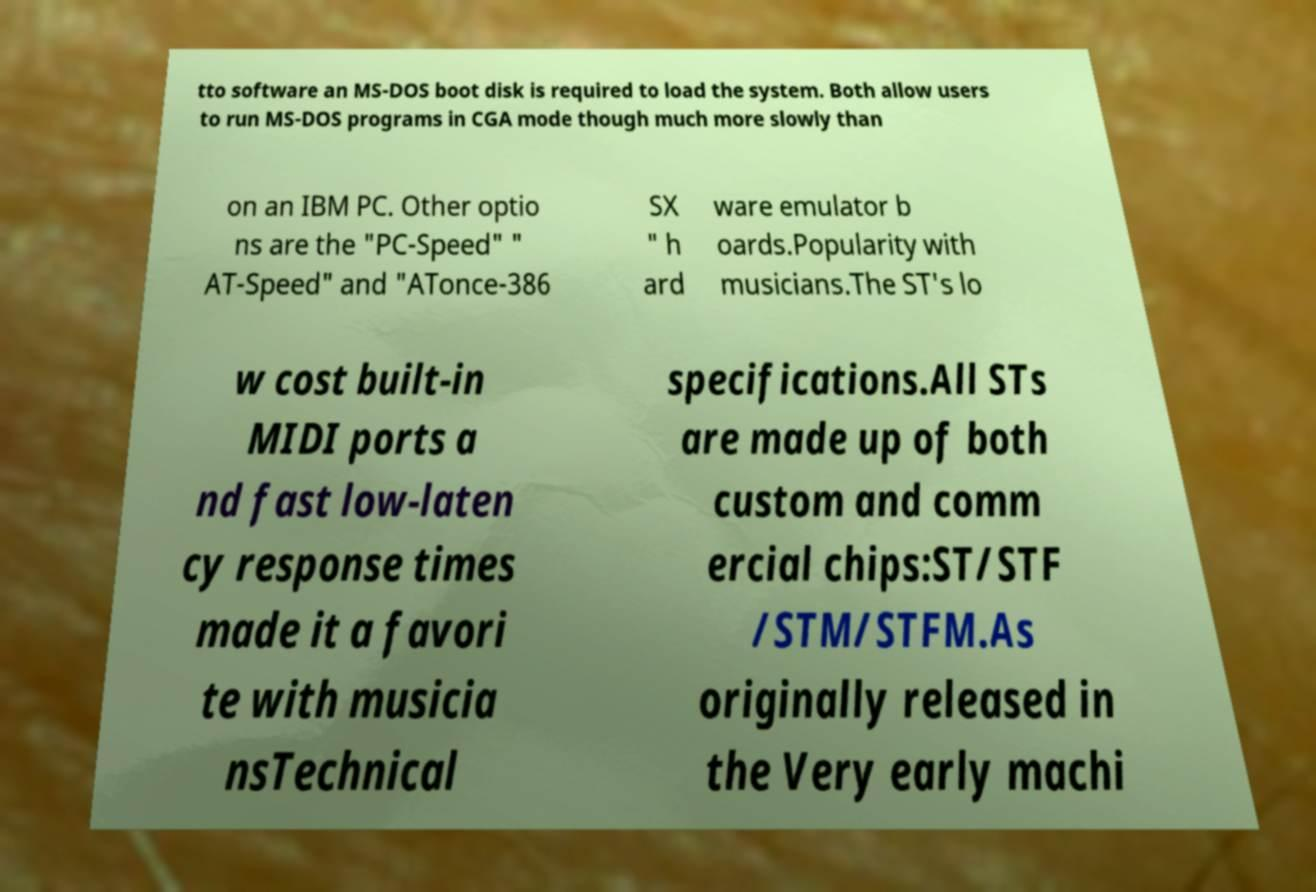For documentation purposes, I need the text within this image transcribed. Could you provide that? tto software an MS-DOS boot disk is required to load the system. Both allow users to run MS-DOS programs in CGA mode though much more slowly than on an IBM PC. Other optio ns are the "PC-Speed" " AT-Speed" and "ATonce-386 SX " h ard ware emulator b oards.Popularity with musicians.The ST's lo w cost built-in MIDI ports a nd fast low-laten cy response times made it a favori te with musicia nsTechnical specifications.All STs are made up of both custom and comm ercial chips:ST/STF /STM/STFM.As originally released in the Very early machi 